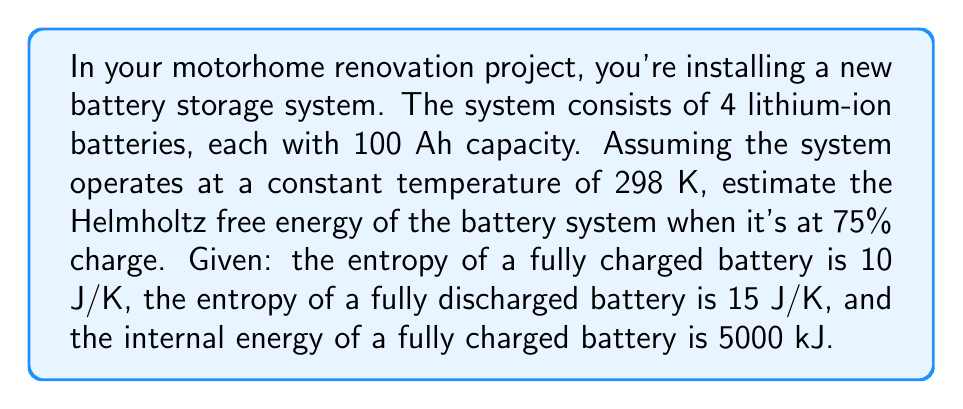Provide a solution to this math problem. To estimate the Helmholtz free energy (F) of the battery system, we'll use the equation:

$$F = U - TS$$

Where U is the internal energy, T is the temperature, and S is the entropy.

Step 1: Calculate the internal energy (U) of the system at 75% charge.
- U for one fully charged battery = 5000 kJ
- U for 4 batteries at 75% charge = 4 × 5000 kJ × 0.75 = 15000 kJ

Step 2: Calculate the entropy (S) of the system at 75% charge.
- S for one fully charged battery = 10 J/K
- S for one fully discharged battery = 15 J/K
- S for one battery at 75% charge = 10 + (15 - 10) × 0.25 = 11.25 J/K
- S for 4 batteries at 75% charge = 4 × 11.25 J/K = 45 J/K

Step 3: Convert entropy to kJ/K for consistency
45 J/K = 0.045 kJ/K

Step 4: Calculate the Helmholtz free energy
$$F = U - TS$$
$$F = 15000 \text{ kJ} - 298 \text{ K} \times 0.045 \text{ kJ/K}$$
$$F = 15000 \text{ kJ} - 13.41 \text{ kJ}$$
$$F = 14986.59 \text{ kJ}$$
Answer: 14986.59 kJ 